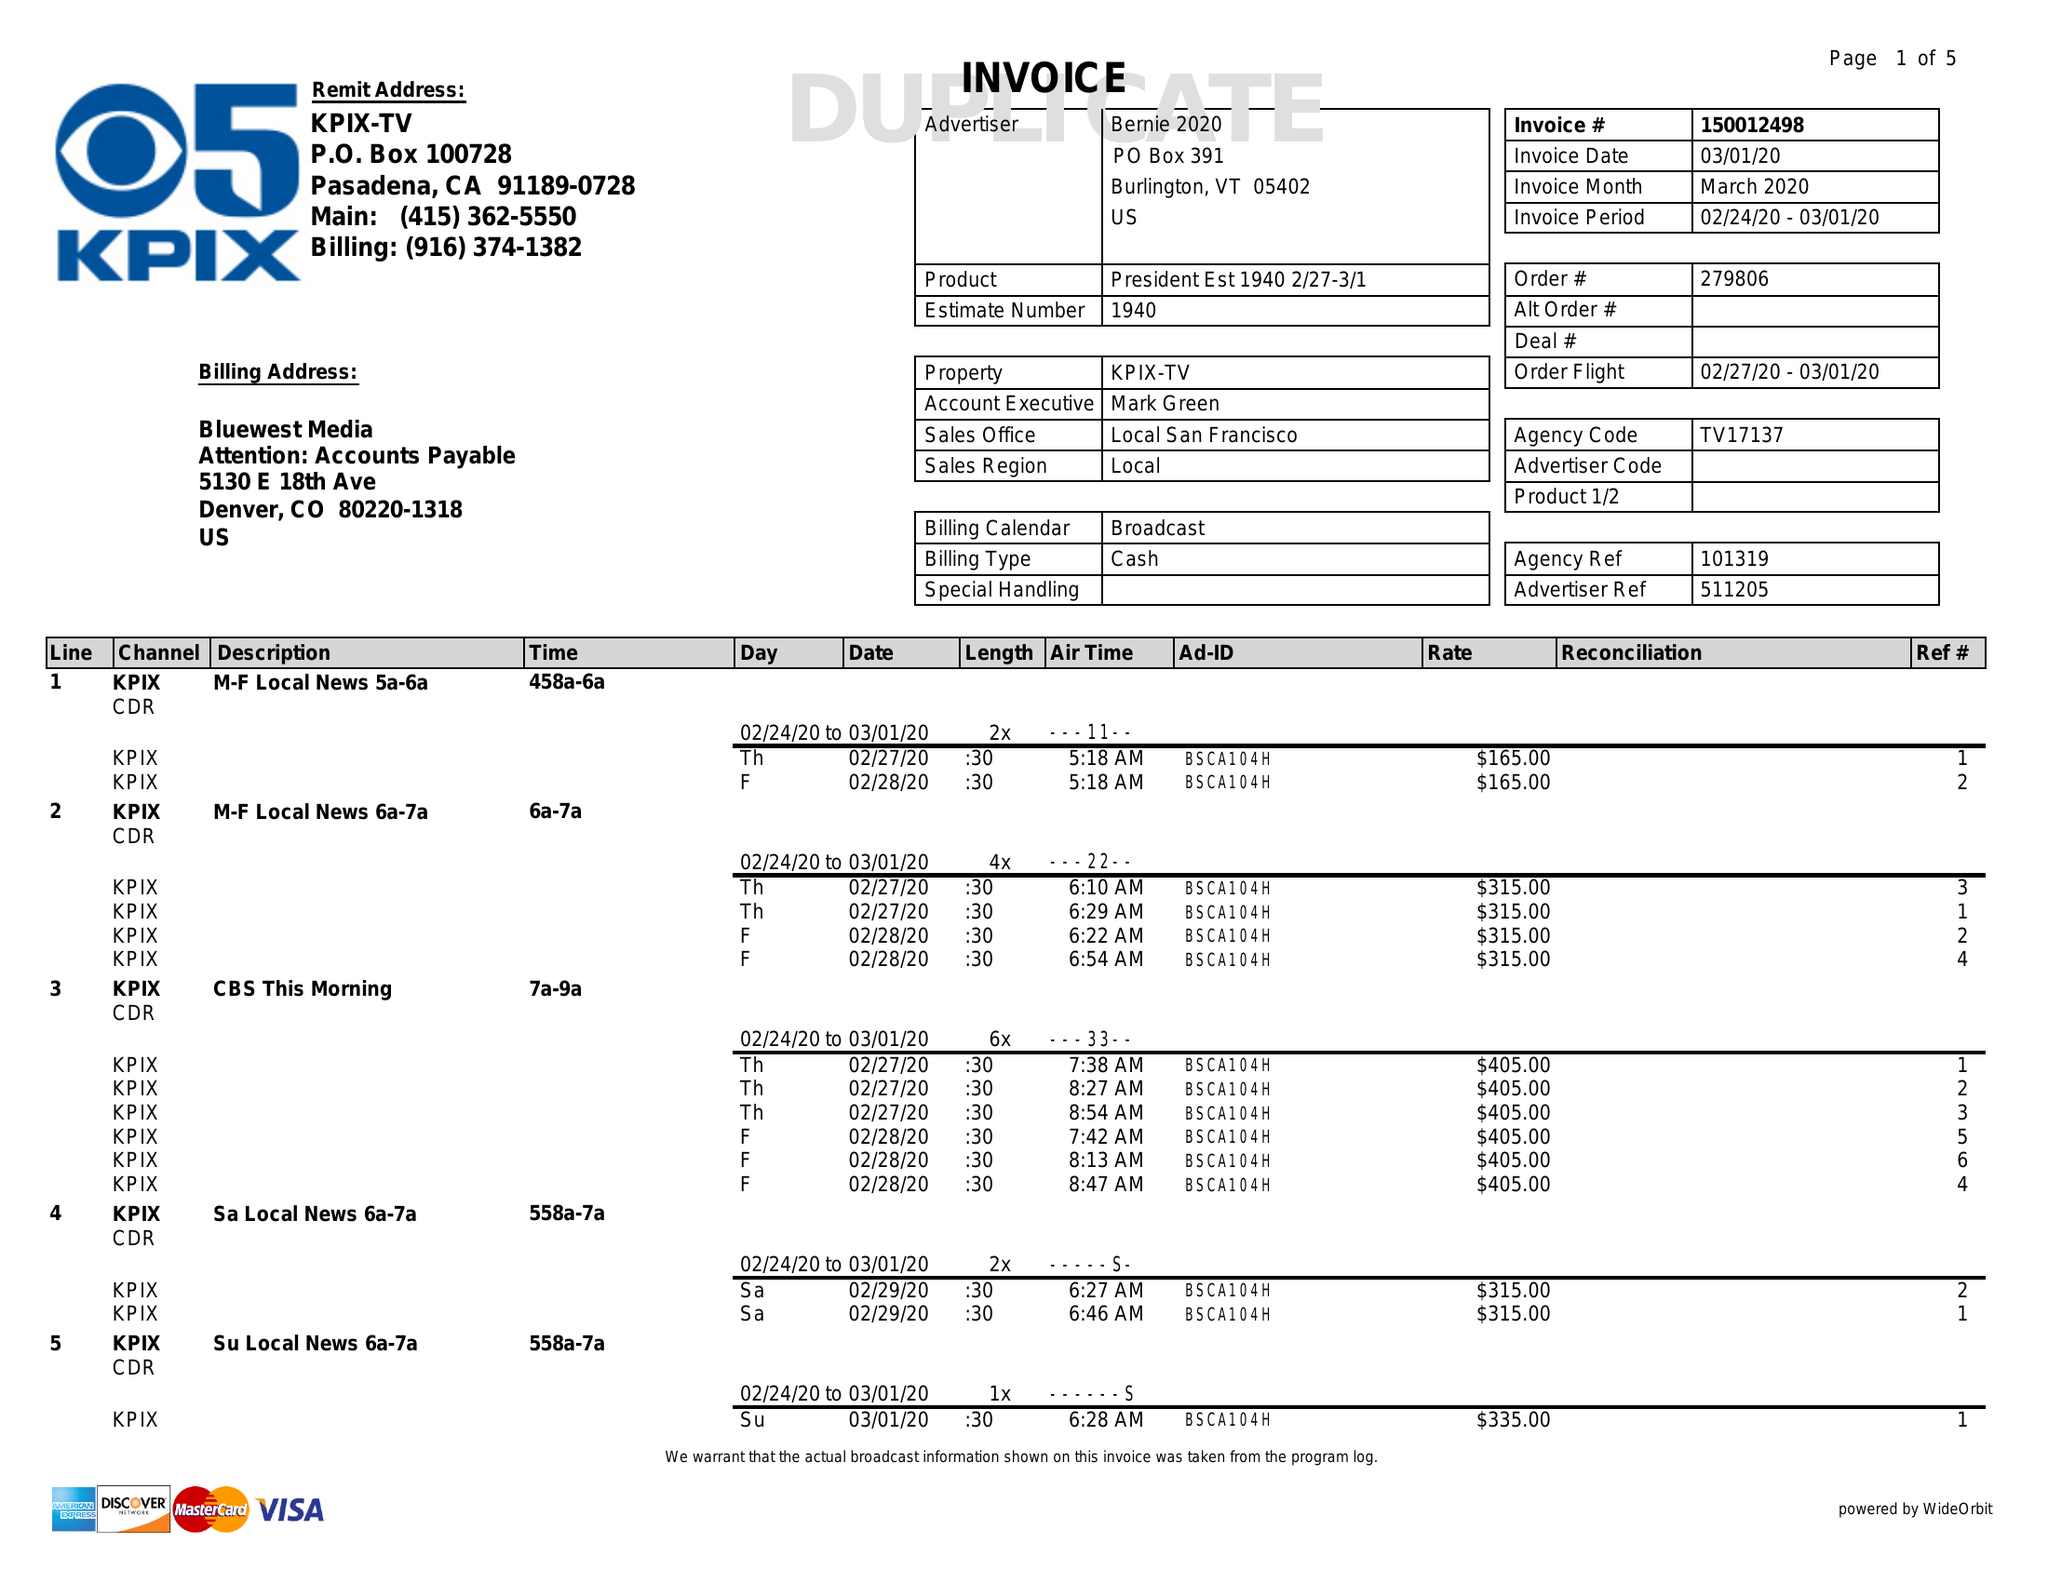What is the value for the flight_to?
Answer the question using a single word or phrase. 03/01/20 